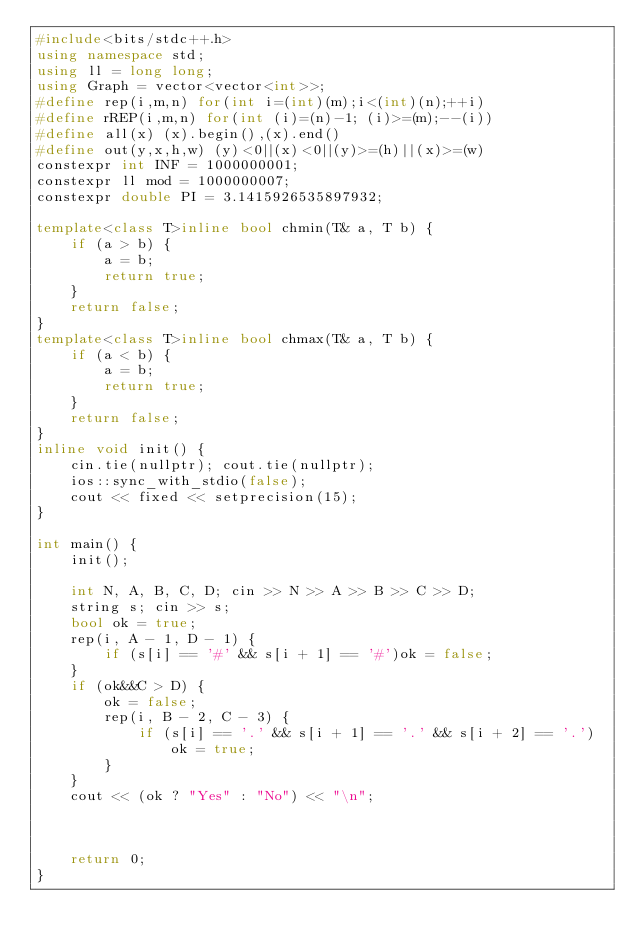Convert code to text. <code><loc_0><loc_0><loc_500><loc_500><_C++_>#include<bits/stdc++.h>
using namespace std;
using ll = long long;
using Graph = vector<vector<int>>;
#define rep(i,m,n) for(int i=(int)(m);i<(int)(n);++i)
#define rREP(i,m,n) for(int (i)=(n)-1; (i)>=(m);--(i))
#define all(x) (x).begin(),(x).end()
#define out(y,x,h,w) (y)<0||(x)<0||(y)>=(h)||(x)>=(w)
constexpr int INF = 1000000001;
constexpr ll mod = 1000000007;
constexpr double PI = 3.1415926535897932;

template<class T>inline bool chmin(T& a, T b) {
	if (a > b) {
		a = b;
		return true;
	}
	return false;
}
template<class T>inline bool chmax(T& a, T b) {
	if (a < b) {
		a = b;
		return true;
	}
	return false;
}
inline void init() {
	cin.tie(nullptr); cout.tie(nullptr);
	ios::sync_with_stdio(false);
	cout << fixed << setprecision(15);
}

int main() {
	init();

	int N, A, B, C, D; cin >> N >> A >> B >> C >> D;
	string s; cin >> s;
	bool ok = true;
	rep(i, A - 1, D - 1) {
		if (s[i] == '#' && s[i + 1] == '#')ok = false;
	}
	if (ok&&C > D) {
		ok = false;
		rep(i, B - 2, C - 3) {
			if (s[i] == '.' && s[i + 1] == '.' && s[i + 2] == '.')ok = true;
		}
	}
	cout << (ok ? "Yes" : "No") << "\n";

	

	return 0;
}</code> 